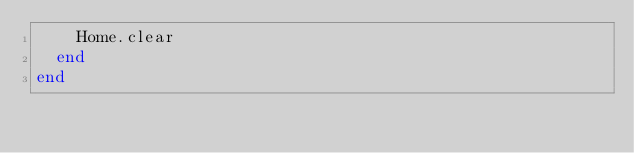Convert code to text. <code><loc_0><loc_0><loc_500><loc_500><_Crystal_>    Home.clear
  end
end
</code> 